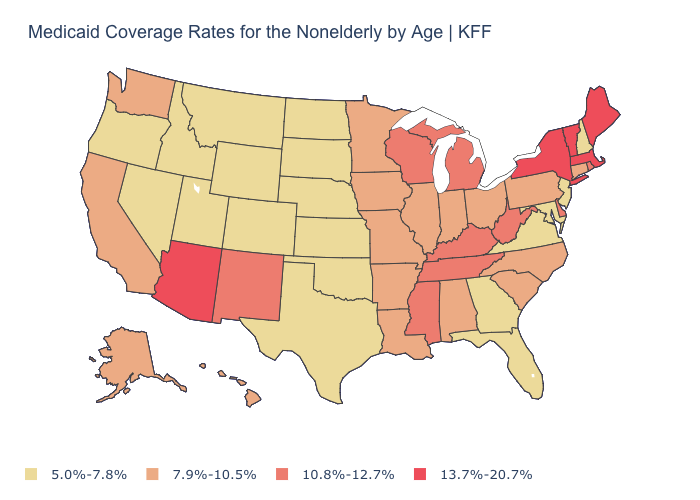What is the highest value in the USA?
Quick response, please. 13.7%-20.7%. Does Rhode Island have the same value as Kentucky?
Keep it brief. Yes. Name the states that have a value in the range 7.9%-10.5%?
Be succinct. Alabama, Alaska, Arkansas, California, Connecticut, Hawaii, Illinois, Indiana, Iowa, Louisiana, Minnesota, Missouri, North Carolina, Ohio, Pennsylvania, South Carolina, Washington. What is the value of Georgia?
Keep it brief. 5.0%-7.8%. What is the highest value in the USA?
Answer briefly. 13.7%-20.7%. Among the states that border Michigan , does Ohio have the highest value?
Write a very short answer. No. Which states have the lowest value in the USA?
Answer briefly. Colorado, Florida, Georgia, Idaho, Kansas, Maryland, Montana, Nebraska, Nevada, New Hampshire, New Jersey, North Dakota, Oklahoma, Oregon, South Dakota, Texas, Utah, Virginia, Wyoming. Which states hav the highest value in the West?
Short answer required. Arizona. What is the value of Minnesota?
Answer briefly. 7.9%-10.5%. What is the lowest value in the USA?
Answer briefly. 5.0%-7.8%. What is the highest value in the USA?
Quick response, please. 13.7%-20.7%. Does Indiana have the lowest value in the MidWest?
Keep it brief. No. What is the value of Connecticut?
Concise answer only. 7.9%-10.5%. What is the value of Kansas?
Quick response, please. 5.0%-7.8%. Does Pennsylvania have a higher value than Illinois?
Be succinct. No. 